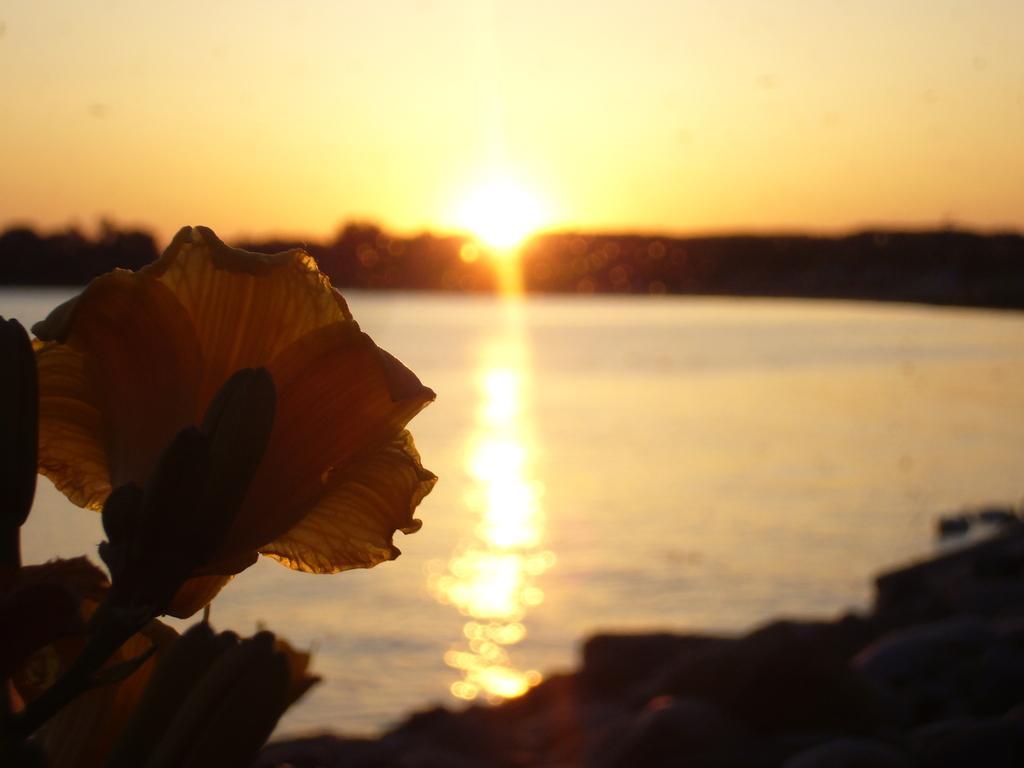What is present in the image? There is a flower in the image. What else can be seen in the image besides the flower? There is water visible in the image. What is visible in the background of the image? There is sky visible in the background of the image. Can the sun be seen in the sky? Yes, the sun is observable in the sky. What type of help can be provided to the flower in the image? There is no indication in the image that the flower needs help, and therefore no such assistance can be provided. 